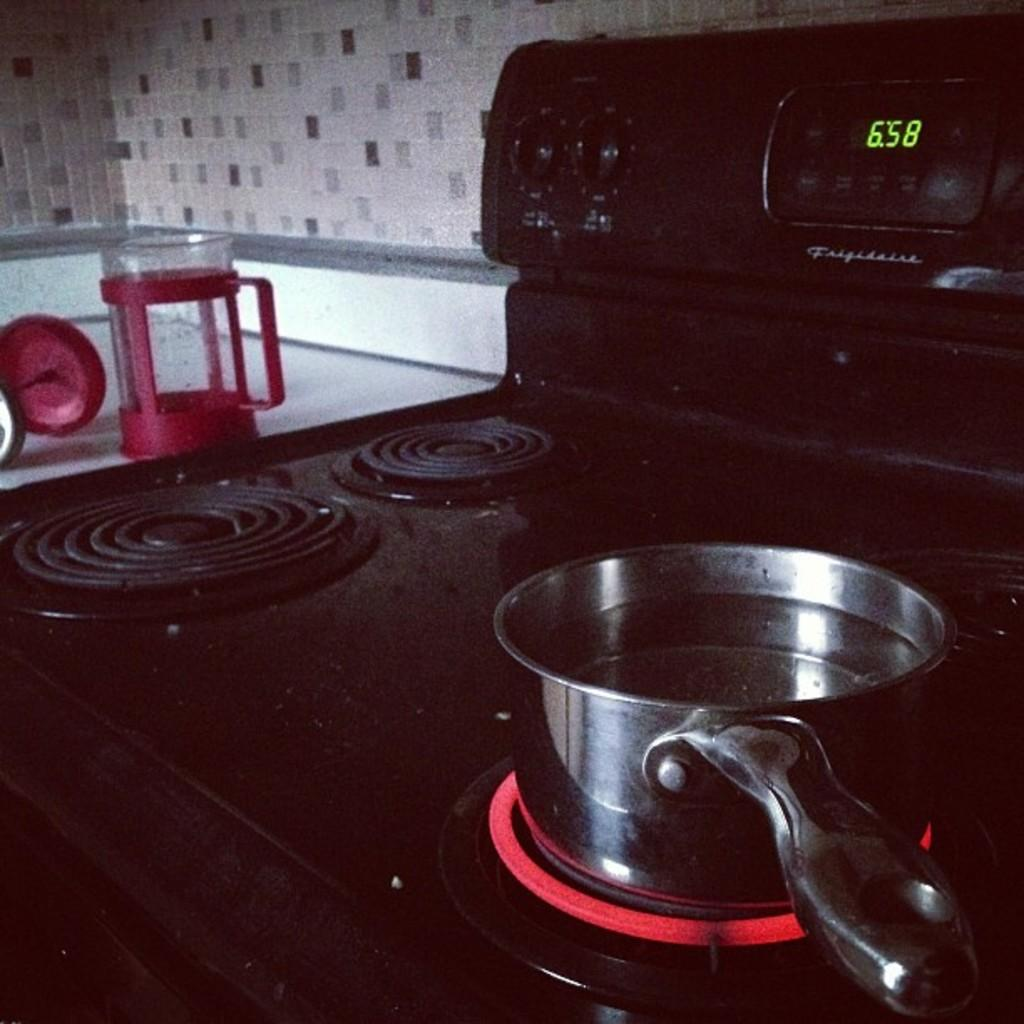<image>
Relay a brief, clear account of the picture shown. It's 6:58 on this stove made by Frigidaire and that has one burner on high. 